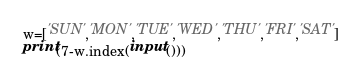Convert code to text. <code><loc_0><loc_0><loc_500><loc_500><_Python_>w=['SUN','MON','TUE','WED','THU','FRI','SAT']
print(7-w.index(input()))</code> 